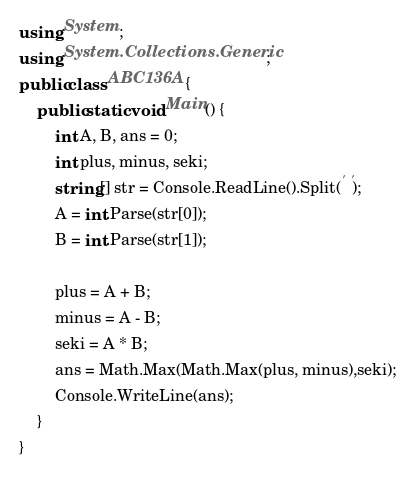Convert code to text. <code><loc_0><loc_0><loc_500><loc_500><_C#_>using System;
using System.Collections.Generic;
public class ABC136A {
    public static void Main() {
        int A, B, ans = 0;
        int plus, minus, seki;
        string[] str = Console.ReadLine().Split(' ');
        A = int.Parse(str[0]);
        B = int.Parse(str[1]);

        plus = A + B;
        minus = A - B;
        seki = A * B;
        ans = Math.Max(Math.Max(plus, minus),seki);
        Console.WriteLine(ans);
    }
}
</code> 